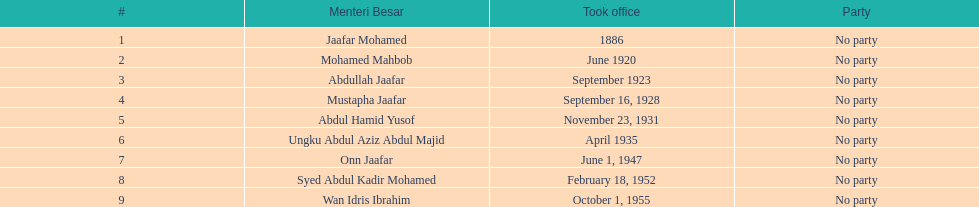What was the date the last person on the list left office? August 31, 1957. 